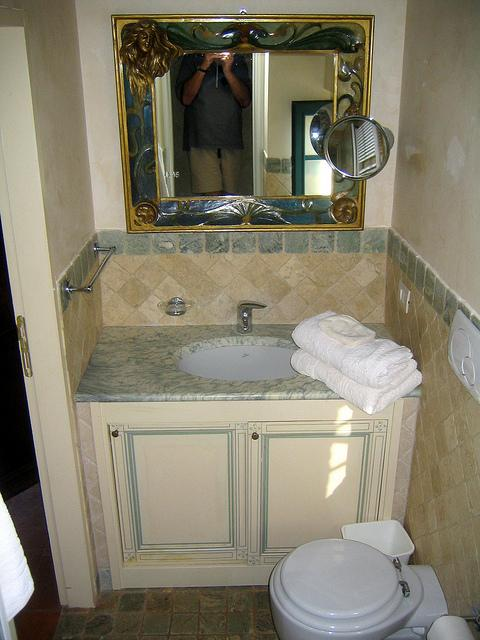What type of mirror is the small circular one referred to as? magnifying 